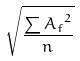<formula> <loc_0><loc_0><loc_500><loc_500>\sqrt { \frac { \sum { A _ { f } } ^ { 2 } } { n } }</formula> 